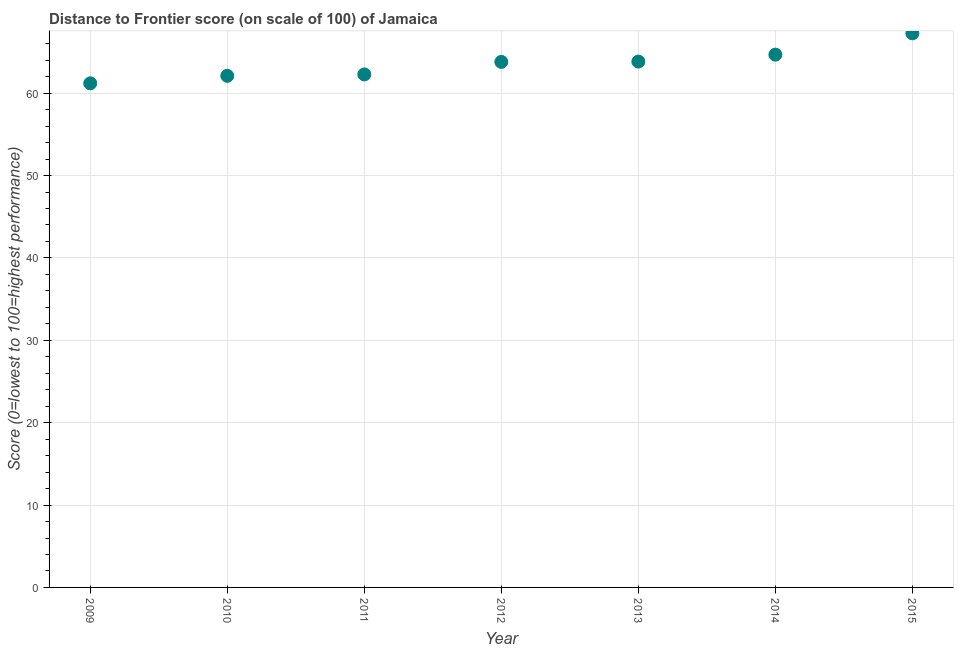What is the distance to frontier score in 2011?
Keep it short and to the point. 62.28. Across all years, what is the maximum distance to frontier score?
Your answer should be compact. 67.27. Across all years, what is the minimum distance to frontier score?
Give a very brief answer. 61.2. In which year was the distance to frontier score maximum?
Your response must be concise. 2015. In which year was the distance to frontier score minimum?
Provide a succinct answer. 2009. What is the sum of the distance to frontier score?
Offer a terse response. 445.18. What is the difference between the distance to frontier score in 2009 and 2010?
Provide a short and direct response. -0.91. What is the average distance to frontier score per year?
Offer a very short reply. 63.6. What is the median distance to frontier score?
Give a very brief answer. 63.8. Do a majority of the years between 2014 and 2013 (inclusive) have distance to frontier score greater than 54 ?
Give a very brief answer. No. What is the ratio of the distance to frontier score in 2012 to that in 2013?
Your response must be concise. 1. Is the difference between the distance to frontier score in 2012 and 2015 greater than the difference between any two years?
Provide a succinct answer. No. What is the difference between the highest and the second highest distance to frontier score?
Give a very brief answer. 2.59. Is the sum of the distance to frontier score in 2012 and 2013 greater than the maximum distance to frontier score across all years?
Ensure brevity in your answer.  Yes. What is the difference between the highest and the lowest distance to frontier score?
Provide a succinct answer. 6.07. Does the distance to frontier score monotonically increase over the years?
Ensure brevity in your answer.  Yes. How many dotlines are there?
Give a very brief answer. 1. What is the difference between two consecutive major ticks on the Y-axis?
Keep it short and to the point. 10. Are the values on the major ticks of Y-axis written in scientific E-notation?
Offer a very short reply. No. Does the graph contain any zero values?
Offer a terse response. No. What is the title of the graph?
Your response must be concise. Distance to Frontier score (on scale of 100) of Jamaica. What is the label or title of the Y-axis?
Provide a short and direct response. Score (0=lowest to 100=highest performance). What is the Score (0=lowest to 100=highest performance) in 2009?
Your answer should be compact. 61.2. What is the Score (0=lowest to 100=highest performance) in 2010?
Your response must be concise. 62.11. What is the Score (0=lowest to 100=highest performance) in 2011?
Provide a succinct answer. 62.28. What is the Score (0=lowest to 100=highest performance) in 2012?
Make the answer very short. 63.8. What is the Score (0=lowest to 100=highest performance) in 2013?
Give a very brief answer. 63.84. What is the Score (0=lowest to 100=highest performance) in 2014?
Ensure brevity in your answer.  64.68. What is the Score (0=lowest to 100=highest performance) in 2015?
Provide a short and direct response. 67.27. What is the difference between the Score (0=lowest to 100=highest performance) in 2009 and 2010?
Give a very brief answer. -0.91. What is the difference between the Score (0=lowest to 100=highest performance) in 2009 and 2011?
Offer a terse response. -1.08. What is the difference between the Score (0=lowest to 100=highest performance) in 2009 and 2013?
Your answer should be compact. -2.64. What is the difference between the Score (0=lowest to 100=highest performance) in 2009 and 2014?
Give a very brief answer. -3.48. What is the difference between the Score (0=lowest to 100=highest performance) in 2009 and 2015?
Ensure brevity in your answer.  -6.07. What is the difference between the Score (0=lowest to 100=highest performance) in 2010 and 2011?
Your answer should be compact. -0.17. What is the difference between the Score (0=lowest to 100=highest performance) in 2010 and 2012?
Offer a very short reply. -1.69. What is the difference between the Score (0=lowest to 100=highest performance) in 2010 and 2013?
Ensure brevity in your answer.  -1.73. What is the difference between the Score (0=lowest to 100=highest performance) in 2010 and 2014?
Your answer should be compact. -2.57. What is the difference between the Score (0=lowest to 100=highest performance) in 2010 and 2015?
Ensure brevity in your answer.  -5.16. What is the difference between the Score (0=lowest to 100=highest performance) in 2011 and 2012?
Make the answer very short. -1.52. What is the difference between the Score (0=lowest to 100=highest performance) in 2011 and 2013?
Offer a terse response. -1.56. What is the difference between the Score (0=lowest to 100=highest performance) in 2011 and 2014?
Your answer should be very brief. -2.4. What is the difference between the Score (0=lowest to 100=highest performance) in 2011 and 2015?
Offer a very short reply. -4.99. What is the difference between the Score (0=lowest to 100=highest performance) in 2012 and 2013?
Your response must be concise. -0.04. What is the difference between the Score (0=lowest to 100=highest performance) in 2012 and 2014?
Provide a short and direct response. -0.88. What is the difference between the Score (0=lowest to 100=highest performance) in 2012 and 2015?
Offer a terse response. -3.47. What is the difference between the Score (0=lowest to 100=highest performance) in 2013 and 2014?
Your answer should be very brief. -0.84. What is the difference between the Score (0=lowest to 100=highest performance) in 2013 and 2015?
Offer a very short reply. -3.43. What is the difference between the Score (0=lowest to 100=highest performance) in 2014 and 2015?
Your answer should be compact. -2.59. What is the ratio of the Score (0=lowest to 100=highest performance) in 2009 to that in 2010?
Keep it short and to the point. 0.98. What is the ratio of the Score (0=lowest to 100=highest performance) in 2009 to that in 2011?
Ensure brevity in your answer.  0.98. What is the ratio of the Score (0=lowest to 100=highest performance) in 2009 to that in 2013?
Offer a very short reply. 0.96. What is the ratio of the Score (0=lowest to 100=highest performance) in 2009 to that in 2014?
Your response must be concise. 0.95. What is the ratio of the Score (0=lowest to 100=highest performance) in 2009 to that in 2015?
Your response must be concise. 0.91. What is the ratio of the Score (0=lowest to 100=highest performance) in 2010 to that in 2012?
Keep it short and to the point. 0.97. What is the ratio of the Score (0=lowest to 100=highest performance) in 2010 to that in 2013?
Make the answer very short. 0.97. What is the ratio of the Score (0=lowest to 100=highest performance) in 2010 to that in 2014?
Keep it short and to the point. 0.96. What is the ratio of the Score (0=lowest to 100=highest performance) in 2010 to that in 2015?
Offer a terse response. 0.92. What is the ratio of the Score (0=lowest to 100=highest performance) in 2011 to that in 2012?
Offer a very short reply. 0.98. What is the ratio of the Score (0=lowest to 100=highest performance) in 2011 to that in 2013?
Make the answer very short. 0.98. What is the ratio of the Score (0=lowest to 100=highest performance) in 2011 to that in 2014?
Provide a succinct answer. 0.96. What is the ratio of the Score (0=lowest to 100=highest performance) in 2011 to that in 2015?
Your response must be concise. 0.93. What is the ratio of the Score (0=lowest to 100=highest performance) in 2012 to that in 2013?
Make the answer very short. 1. What is the ratio of the Score (0=lowest to 100=highest performance) in 2012 to that in 2014?
Ensure brevity in your answer.  0.99. What is the ratio of the Score (0=lowest to 100=highest performance) in 2012 to that in 2015?
Provide a short and direct response. 0.95. What is the ratio of the Score (0=lowest to 100=highest performance) in 2013 to that in 2015?
Provide a short and direct response. 0.95. What is the ratio of the Score (0=lowest to 100=highest performance) in 2014 to that in 2015?
Ensure brevity in your answer.  0.96. 